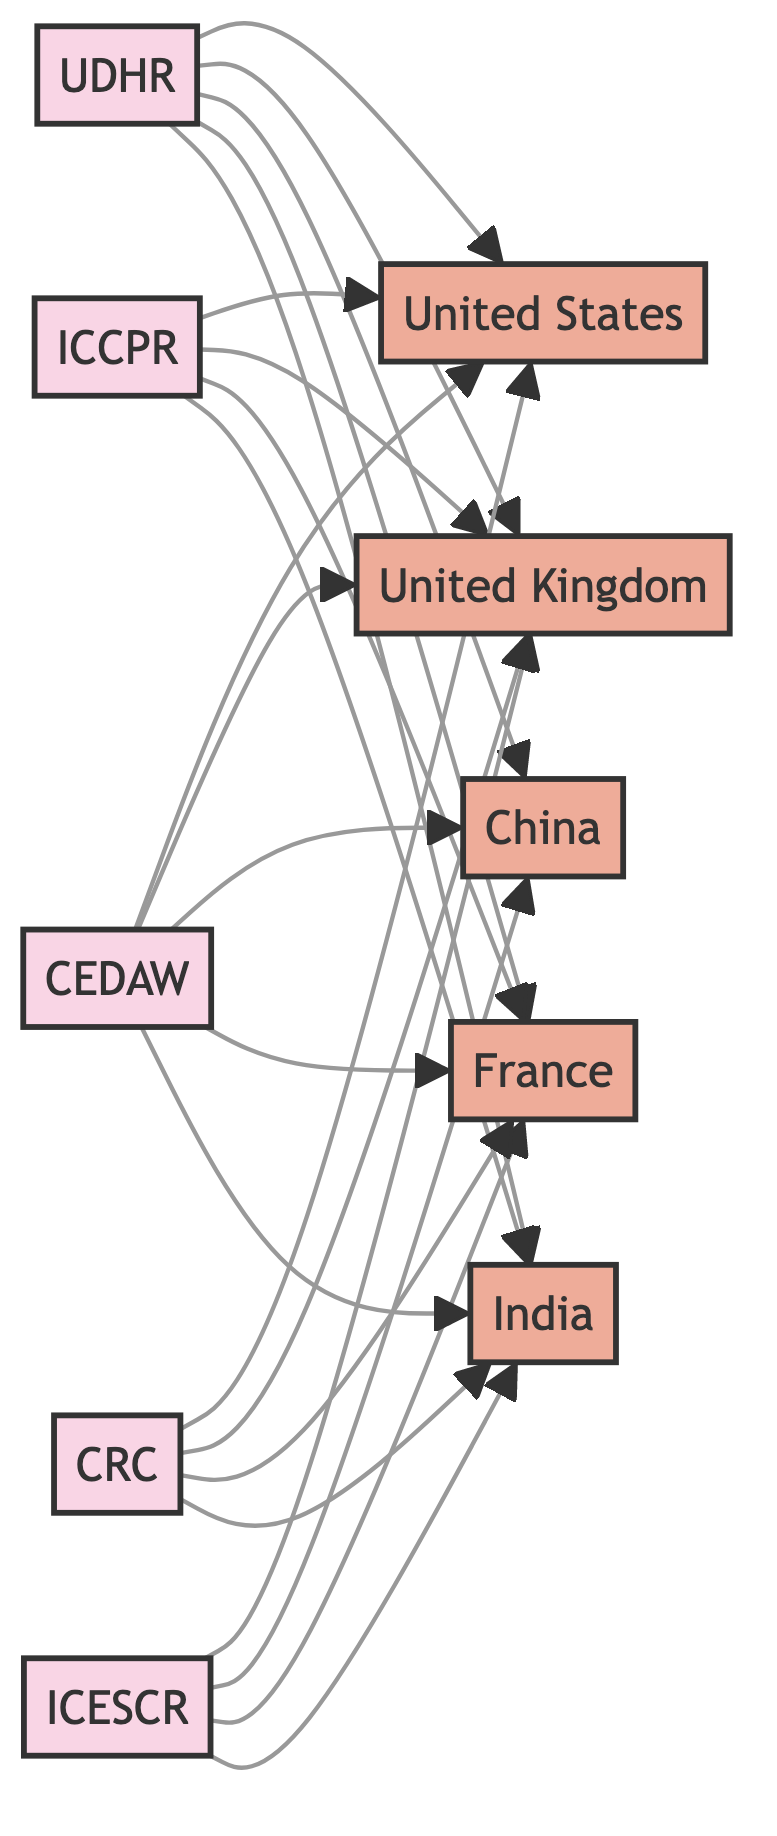What is the total number of treaties represented in the diagram? The diagram contains five distinct treaties listed as nodes: UDHR, ICCPR, ICESCR, CEDAW, and CRC. Counting these nodes gives us the total number of treaties.
Answer: 5 Which country is connected to the Convention on the Elimination of All Forms of Discrimination Against Women? The diagram shows connections from the treaty CEDAW to various countries. By checking the links from CEDAW, we find that it connects to the United States, United Kingdom, China, France, and India.
Answer: United States, United Kingdom, China, France, India How many countries are signatories to the International Covenant on Civil and Political Rights? By examining the connections from the ICCPR node, we can count that there are four countries linked to it: United States, United Kingdom, France, and India.
Answer: 4 Which treaty has the most signatories listed in the diagram? To determine the treaty with the most signatories, we look at the connections for each treaty. The UDHR, CEDAW, and CRC have connections to all five countries, while the ICCPR and ICESCR connect to four. Therefore, the treaties with the most signatories are those linked to all five countries.
Answer: UDHR, CEDAW, CRC Is China a signatory to the International Covenant on Economic, Social and Cultural Rights? Checking the links from the ICESCR, we find that China is indeed listed as a signatory among the connected countries.
Answer: Yes How many relationships are formed in total between treaties and signatory countries? The diagram depicts the number of relationships as links between the treaties and the countries. Counting all links, we find that there are a total of 20 connections in the diagram.
Answer: 20 Which country is not a signatory to the International Covenant on Economic, Social and Cultural Rights? By analyzing the connections from the ICESCR, we see which countries are linked. All listed countries are signatories, so we conclude no country is absent from this treaty's signatories.
Answer: None Which two treaties are connected to the United Kingdom? To find this, we assess the two treaties connected by links to the United Kingdom. The treaties are UDHR, ICCPR, ICESCR, CEDAW, and CRC; thus, we verify that all treaties except ICCPR and ICESCR also link to other countries.
Answer: All treaties 